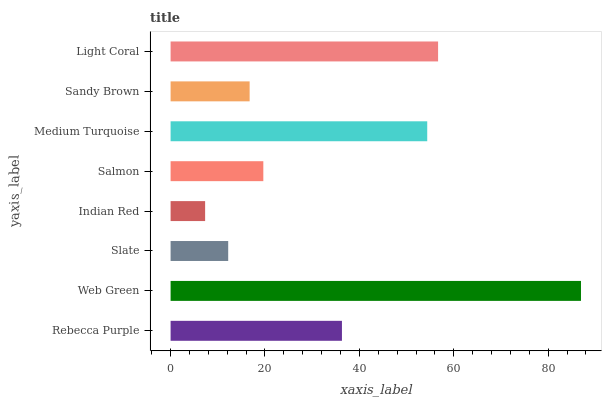Is Indian Red the minimum?
Answer yes or no. Yes. Is Web Green the maximum?
Answer yes or no. Yes. Is Slate the minimum?
Answer yes or no. No. Is Slate the maximum?
Answer yes or no. No. Is Web Green greater than Slate?
Answer yes or no. Yes. Is Slate less than Web Green?
Answer yes or no. Yes. Is Slate greater than Web Green?
Answer yes or no. No. Is Web Green less than Slate?
Answer yes or no. No. Is Rebecca Purple the high median?
Answer yes or no. Yes. Is Salmon the low median?
Answer yes or no. Yes. Is Light Coral the high median?
Answer yes or no. No. Is Slate the low median?
Answer yes or no. No. 